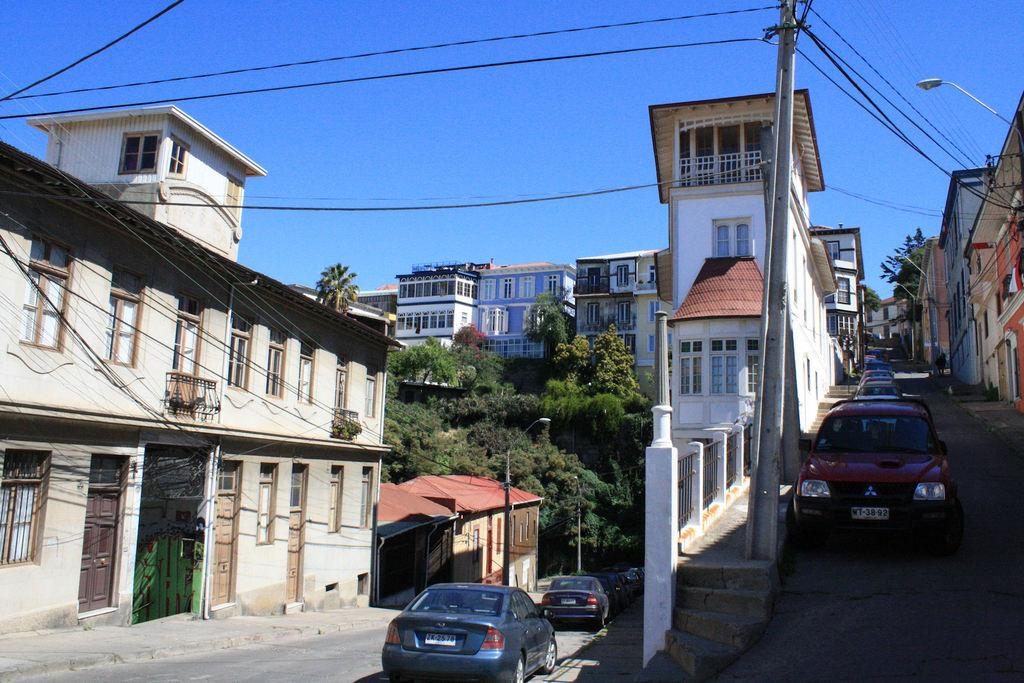What can be seen parked on the side of the road in the image? There are cars parked on the side of the road in the image. What is located near the cars in the image? There is a current pole and wires visible in the image. What type of structures are present in the image? There are buildings in the image. Can you describe any architectural features in the image? Stairs are present in the image. What type of vegetation is visible in the image? Trees are visible in the image. What is the color of the sky in the background of the image? The sky in the background of the image is blue. Where is the writer sitting in the image? There is no writer present in the image. What type of curtain can be seen hanging from the windows in the image? There are no windows or curtains visible in the image. What type of recreational area is shown in the image? There is no park or recreational area shown in the image. 